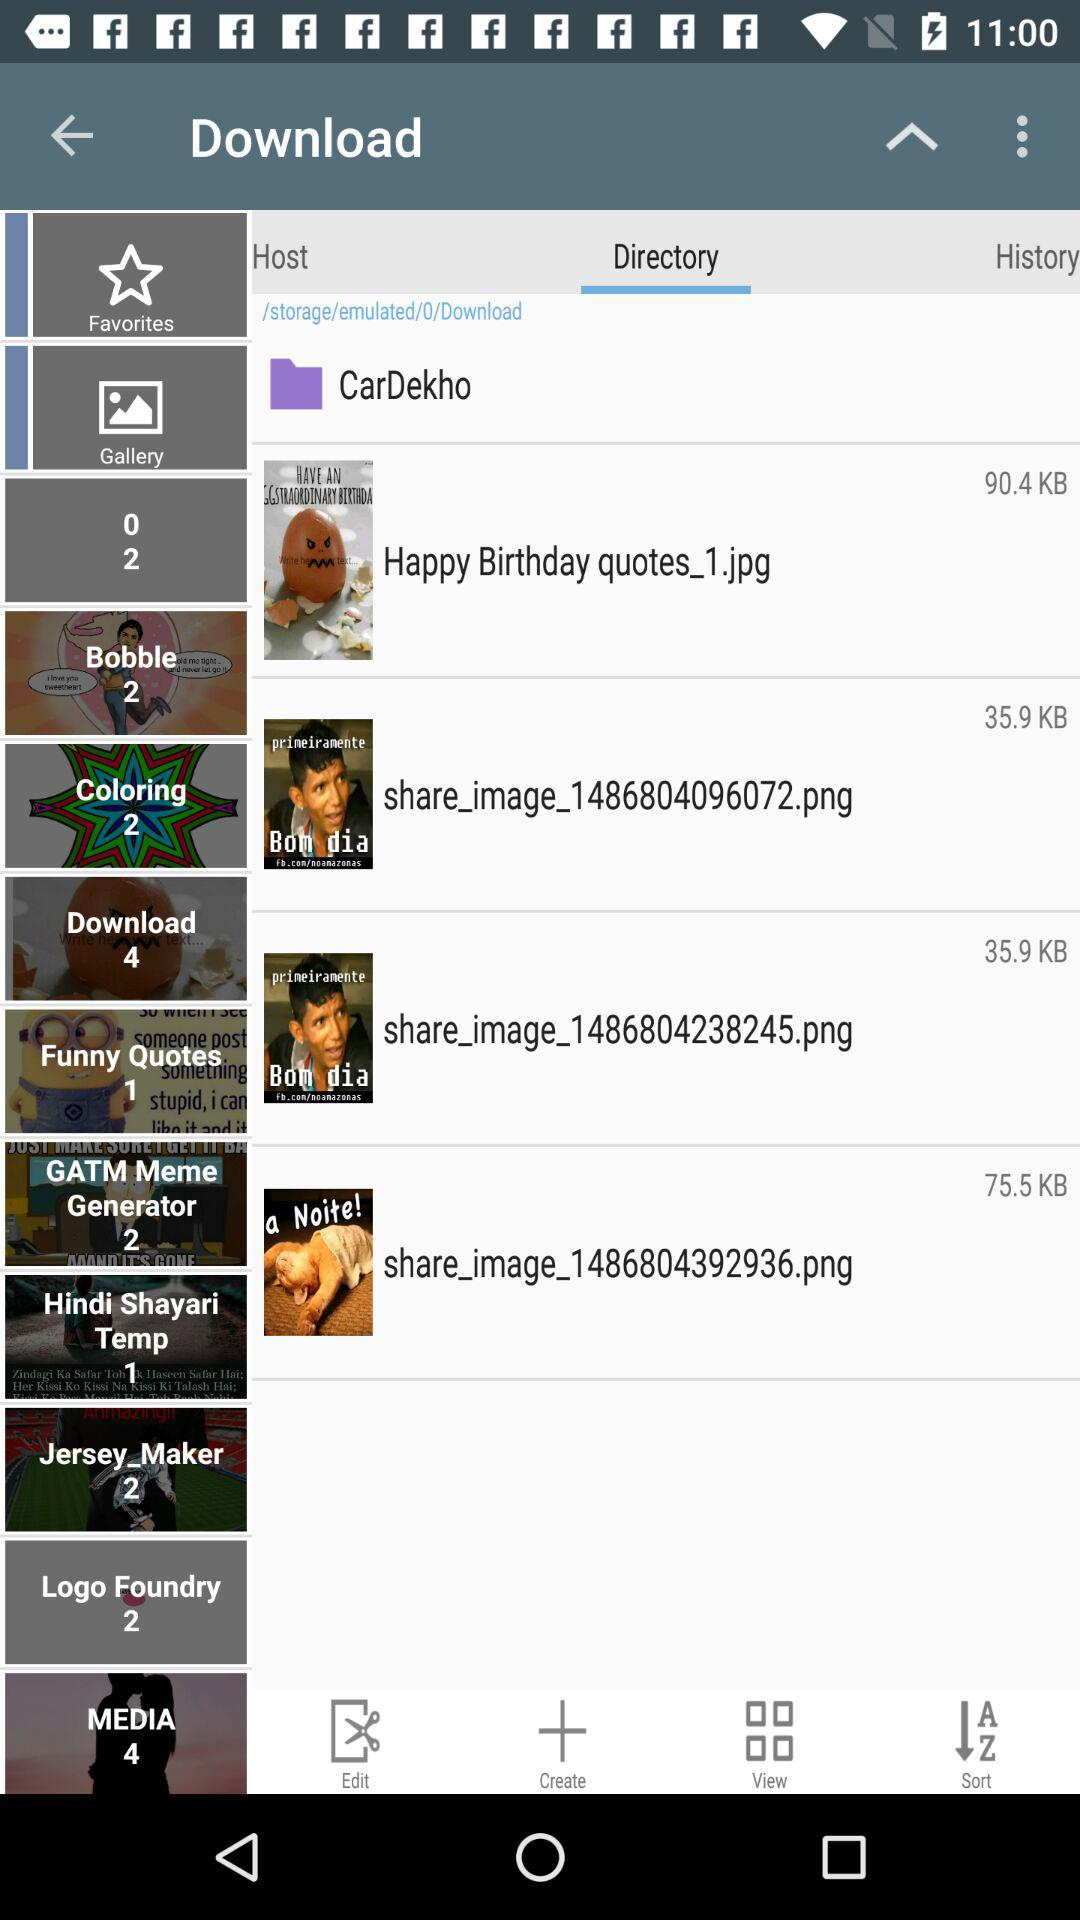How many items are in the funny quotes? There is 1 item. 